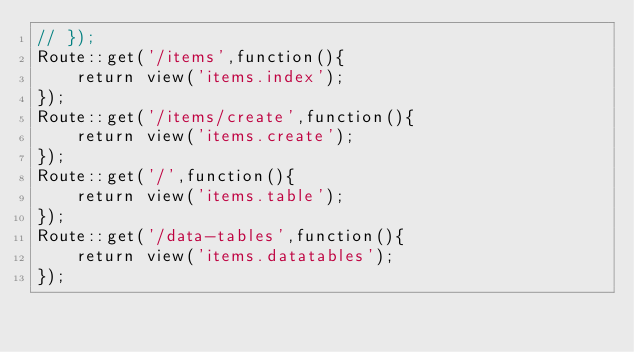<code> <loc_0><loc_0><loc_500><loc_500><_PHP_>// });
Route::get('/items',function(){
    return view('items.index');
});
Route::get('/items/create',function(){
    return view('items.create');
});
Route::get('/',function(){
    return view('items.table');
});
Route::get('/data-tables',function(){
    return view('items.datatables');
});
</code> 